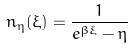<formula> <loc_0><loc_0><loc_500><loc_500>n _ { \eta } ( \xi ) = \frac { 1 } { e ^ { \beta \xi } - \eta }</formula> 